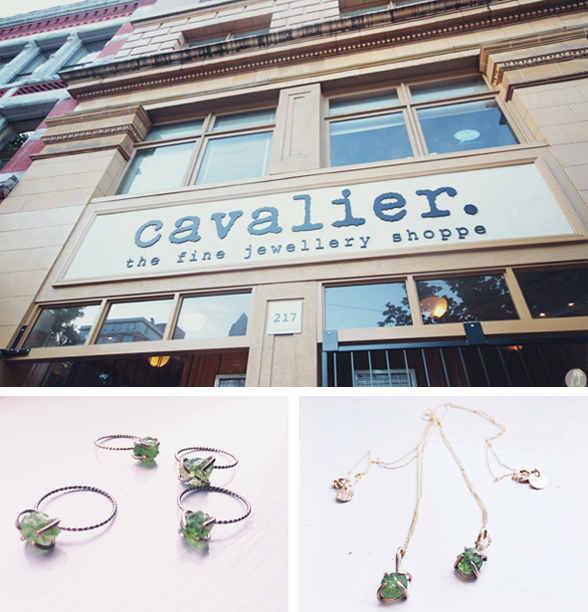Considering the details visible in the photograph of the jewelry, what might be the unique selling proposition (USP) of Cavalier's jewelry collection based on the design and materials visible? Cavalier's jewelry collection distinguishes itself through the use of uniquely large, vividly green gemstones that likely represent rare or premium quality. The juxtaposition of these striking stones with minimalist, dark-hued bands in the rings and a delicately crafted gold chain for the necklace highlights a signature style of elegance balanced with boldness. This collection could appeal to consumers looking for statement pieces that combine traditional gemstone luxury with contemporary design aesthetics. 